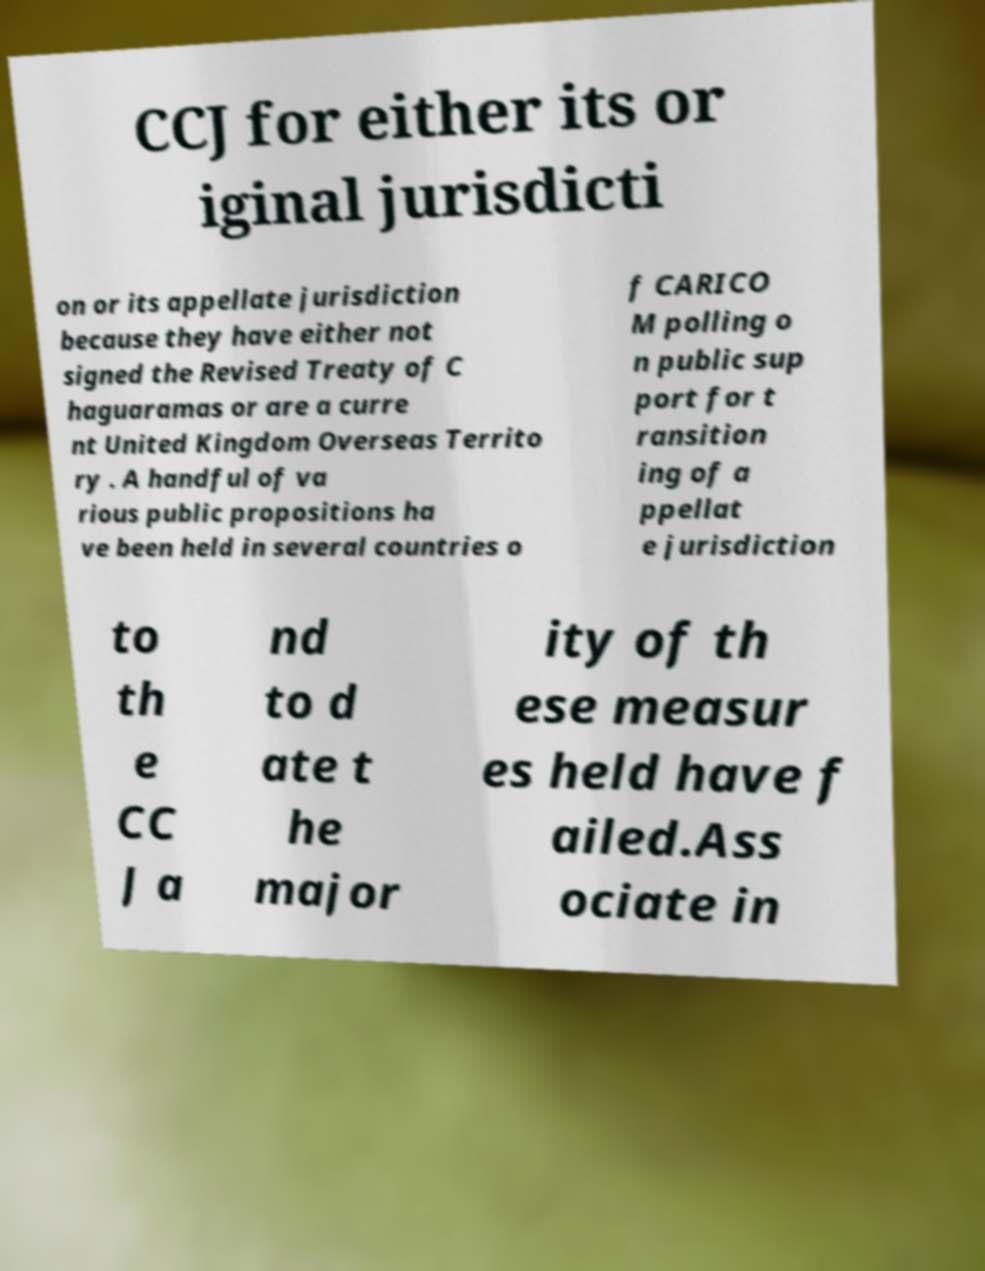For documentation purposes, I need the text within this image transcribed. Could you provide that? CCJ for either its or iginal jurisdicti on or its appellate jurisdiction because they have either not signed the Revised Treaty of C haguaramas or are a curre nt United Kingdom Overseas Territo ry . A handful of va rious public propositions ha ve been held in several countries o f CARICO M polling o n public sup port for t ransition ing of a ppellat e jurisdiction to th e CC J a nd to d ate t he major ity of th ese measur es held have f ailed.Ass ociate in 